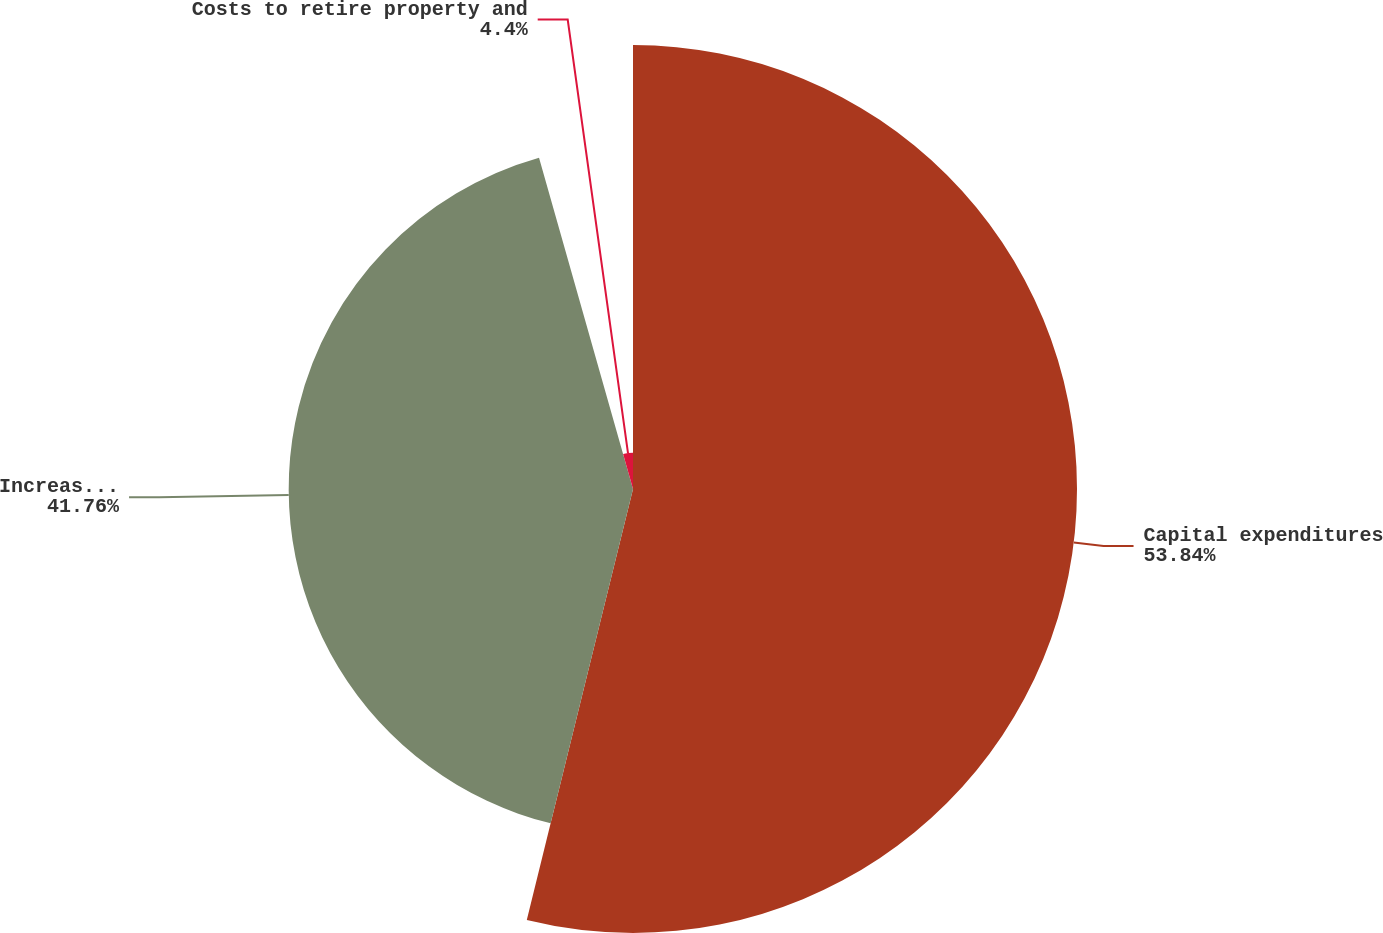<chart> <loc_0><loc_0><loc_500><loc_500><pie_chart><fcel>Capital expenditures<fcel>Increase in EnerBank notes<fcel>Costs to retire property and<nl><fcel>53.85%<fcel>41.76%<fcel>4.4%<nl></chart> 